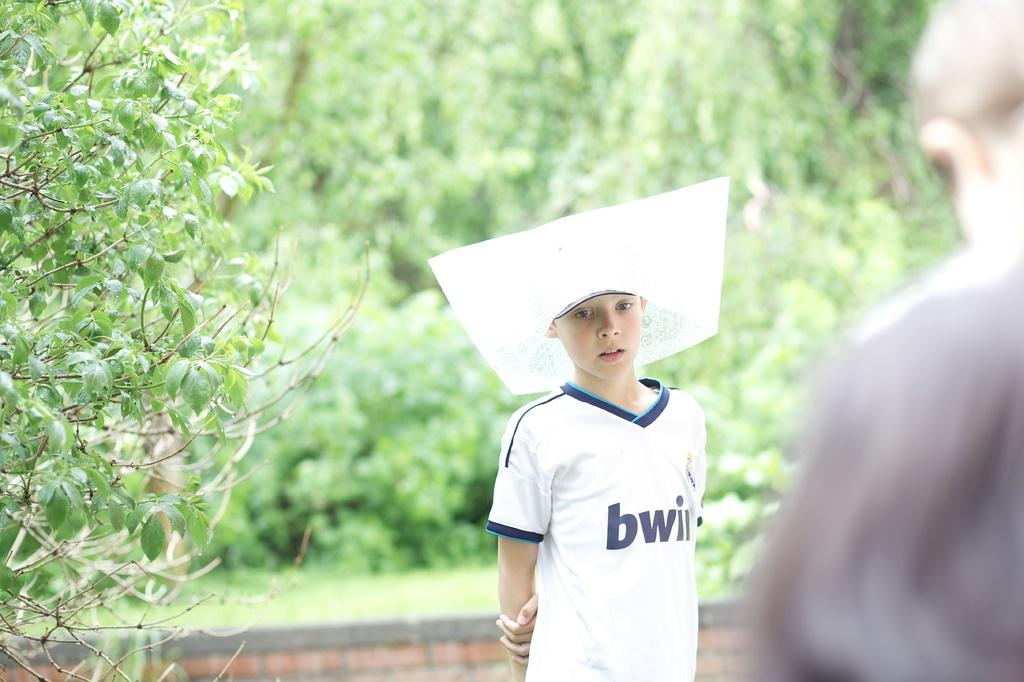<image>
Give a short and clear explanation of the subsequent image. A boy wearing a large hat and wearing a white bwi shirt. 